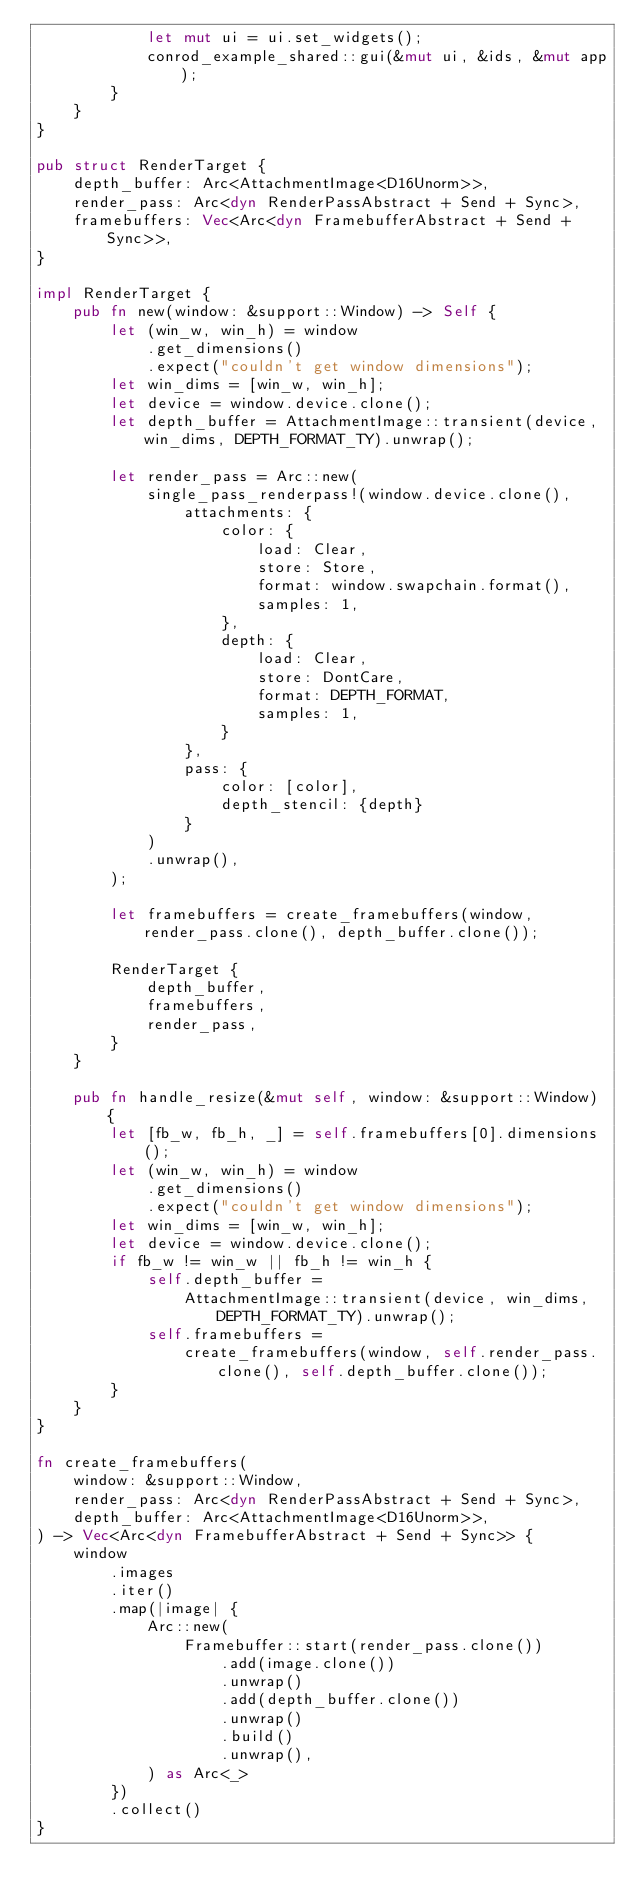Convert code to text. <code><loc_0><loc_0><loc_500><loc_500><_Rust_>            let mut ui = ui.set_widgets();
            conrod_example_shared::gui(&mut ui, &ids, &mut app);
        }
    }
}

pub struct RenderTarget {
    depth_buffer: Arc<AttachmentImage<D16Unorm>>,
    render_pass: Arc<dyn RenderPassAbstract + Send + Sync>,
    framebuffers: Vec<Arc<dyn FramebufferAbstract + Send + Sync>>,
}

impl RenderTarget {
    pub fn new(window: &support::Window) -> Self {
        let (win_w, win_h) = window
            .get_dimensions()
            .expect("couldn't get window dimensions");
        let win_dims = [win_w, win_h];
        let device = window.device.clone();
        let depth_buffer = AttachmentImage::transient(device, win_dims, DEPTH_FORMAT_TY).unwrap();

        let render_pass = Arc::new(
            single_pass_renderpass!(window.device.clone(),
                attachments: {
                    color: {
                        load: Clear,
                        store: Store,
                        format: window.swapchain.format(),
                        samples: 1,
                    },
                    depth: {
                        load: Clear,
                        store: DontCare,
                        format: DEPTH_FORMAT,
                        samples: 1,
                    }
                },
                pass: {
                    color: [color],
                    depth_stencil: {depth}
                }
            )
            .unwrap(),
        );

        let framebuffers = create_framebuffers(window, render_pass.clone(), depth_buffer.clone());

        RenderTarget {
            depth_buffer,
            framebuffers,
            render_pass,
        }
    }

    pub fn handle_resize(&mut self, window: &support::Window) {
        let [fb_w, fb_h, _] = self.framebuffers[0].dimensions();
        let (win_w, win_h) = window
            .get_dimensions()
            .expect("couldn't get window dimensions");
        let win_dims = [win_w, win_h];
        let device = window.device.clone();
        if fb_w != win_w || fb_h != win_h {
            self.depth_buffer =
                AttachmentImage::transient(device, win_dims, DEPTH_FORMAT_TY).unwrap();
            self.framebuffers =
                create_framebuffers(window, self.render_pass.clone(), self.depth_buffer.clone());
        }
    }
}

fn create_framebuffers(
    window: &support::Window,
    render_pass: Arc<dyn RenderPassAbstract + Send + Sync>,
    depth_buffer: Arc<AttachmentImage<D16Unorm>>,
) -> Vec<Arc<dyn FramebufferAbstract + Send + Sync>> {
    window
        .images
        .iter()
        .map(|image| {
            Arc::new(
                Framebuffer::start(render_pass.clone())
                    .add(image.clone())
                    .unwrap()
                    .add(depth_buffer.clone())
                    .unwrap()
                    .build()
                    .unwrap(),
            ) as Arc<_>
        })
        .collect()
}
</code> 